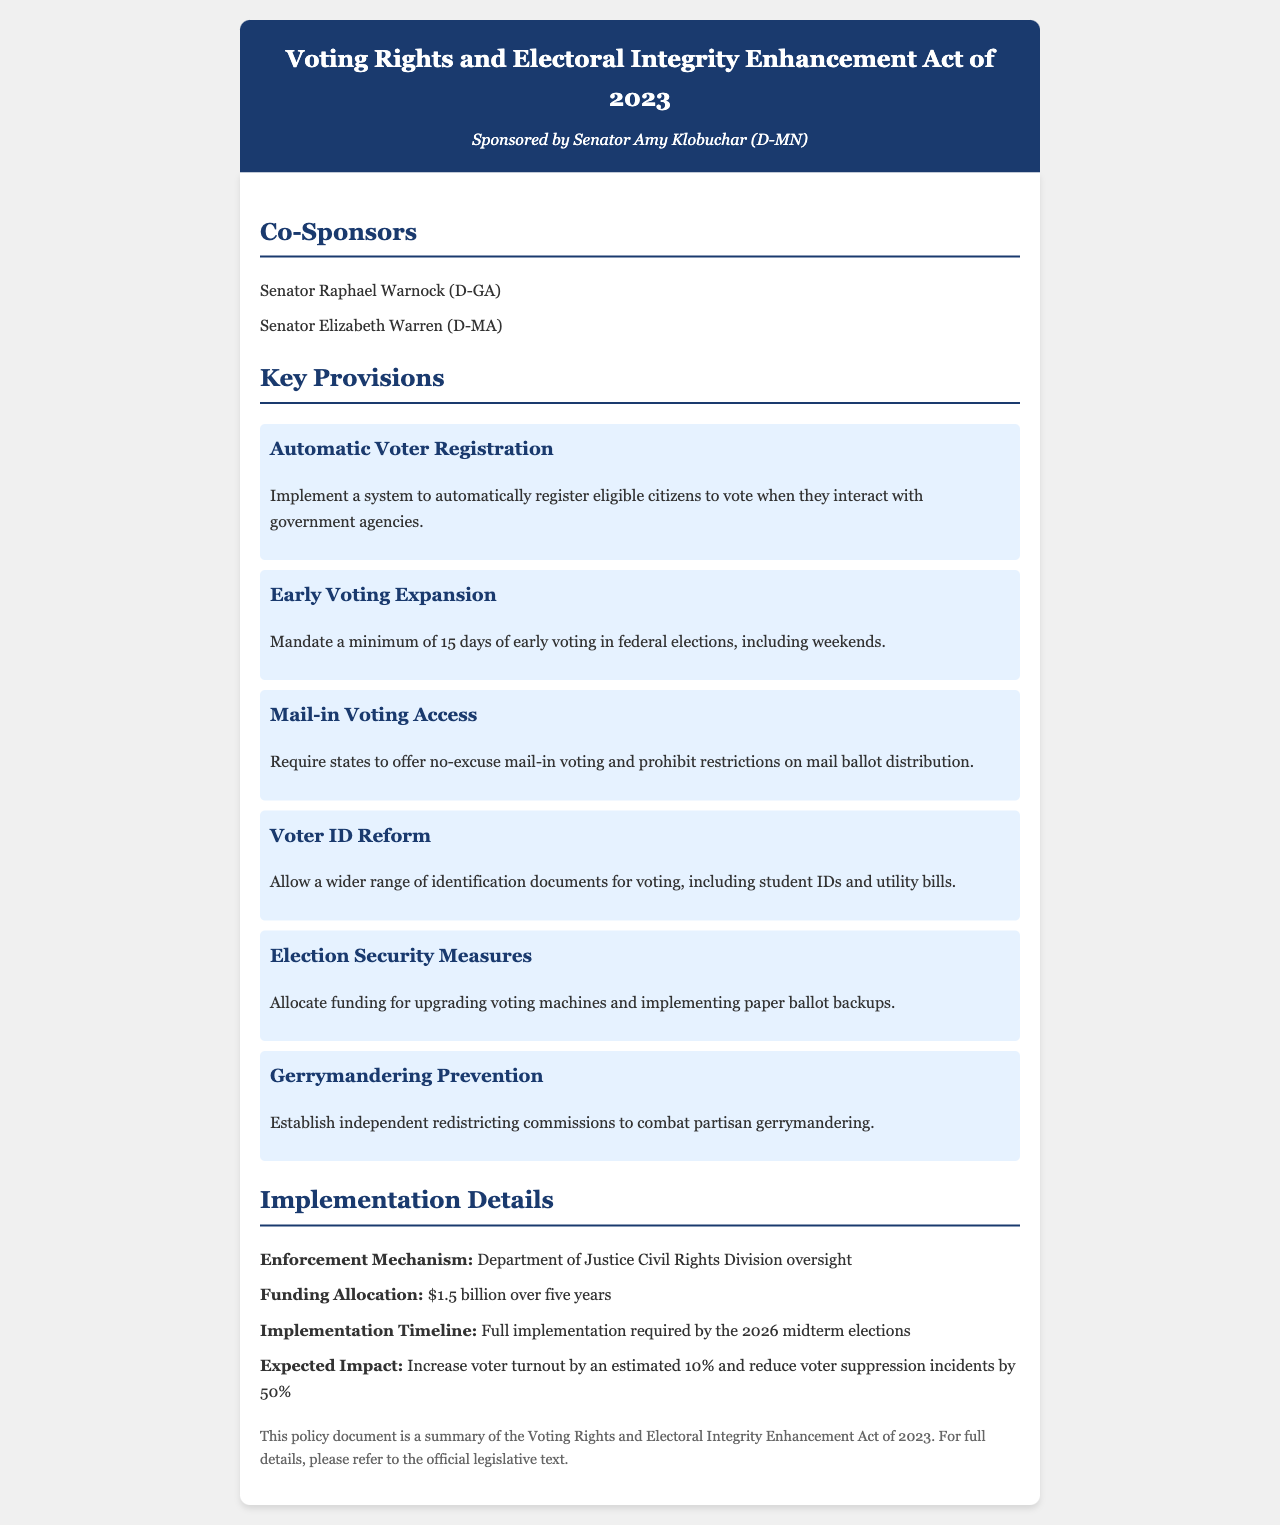What is the title of the policy document? The title is the heading of the document and provides insight into its content, which is "Voting Rights and Electoral Integrity Enhancement Act of 2023."
Answer: Voting Rights and Electoral Integrity Enhancement Act of 2023 Who is the primary sponsor of the legislation? The primary sponsor is the individual or group responsible for introducing the legislation, which is mentioned as Senator Amy Klobuchar (D-MN).
Answer: Senator Amy Klobuchar (D-MN) How many co-sponsors are listed in the document? The number of co-sponsors can be determined by counting the names listed under the Co-Sponsors section, which are two.
Answer: 2 What is the minimum number of days for early voting mandated by the act? This information is found in the specific provision talking about early voting, which states a minimum of 15 days.
Answer: 15 days What is the funding allocation for implementing the provisions? The funding allocation mentioned includes a specific total amount for implementation over a set number of years, which is $1.5 billion over five years.
Answer: $1.5 billion Which department is responsible for enforcing the act? The enforcement mechanism is highlighted in the implementation details, specifying that the Department of Justice Civil Rights Division will oversee it.
Answer: Department of Justice Civil Rights Division What is the expected impact on voter turnout? The document provides a projected increase in voter turnout based on the legislation, which is an estimated 10%.
Answer: 10% What type of voting access does the act require for mail-in voting? The act specifies that states must offer no-excuse mail-in voting as part of the voting access reforms.
Answer: No-excuse mail-in voting What measures are proposed to combat gerrymandering? The provisions aimed at gerrymandering are outlined under a specific heading, indicating the establishment of independent redistricting commissions.
Answer: Independent redistricting commissions 